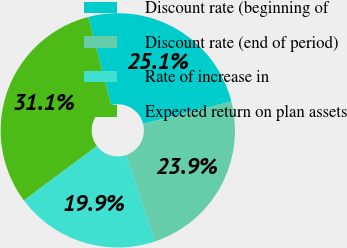<chart> <loc_0><loc_0><loc_500><loc_500><pie_chart><fcel>Discount rate (beginning of<fcel>Discount rate (end of period)<fcel>Rate of increase in<fcel>Expected return on plan assets<nl><fcel>25.1%<fcel>23.86%<fcel>19.92%<fcel>31.12%<nl></chart> 